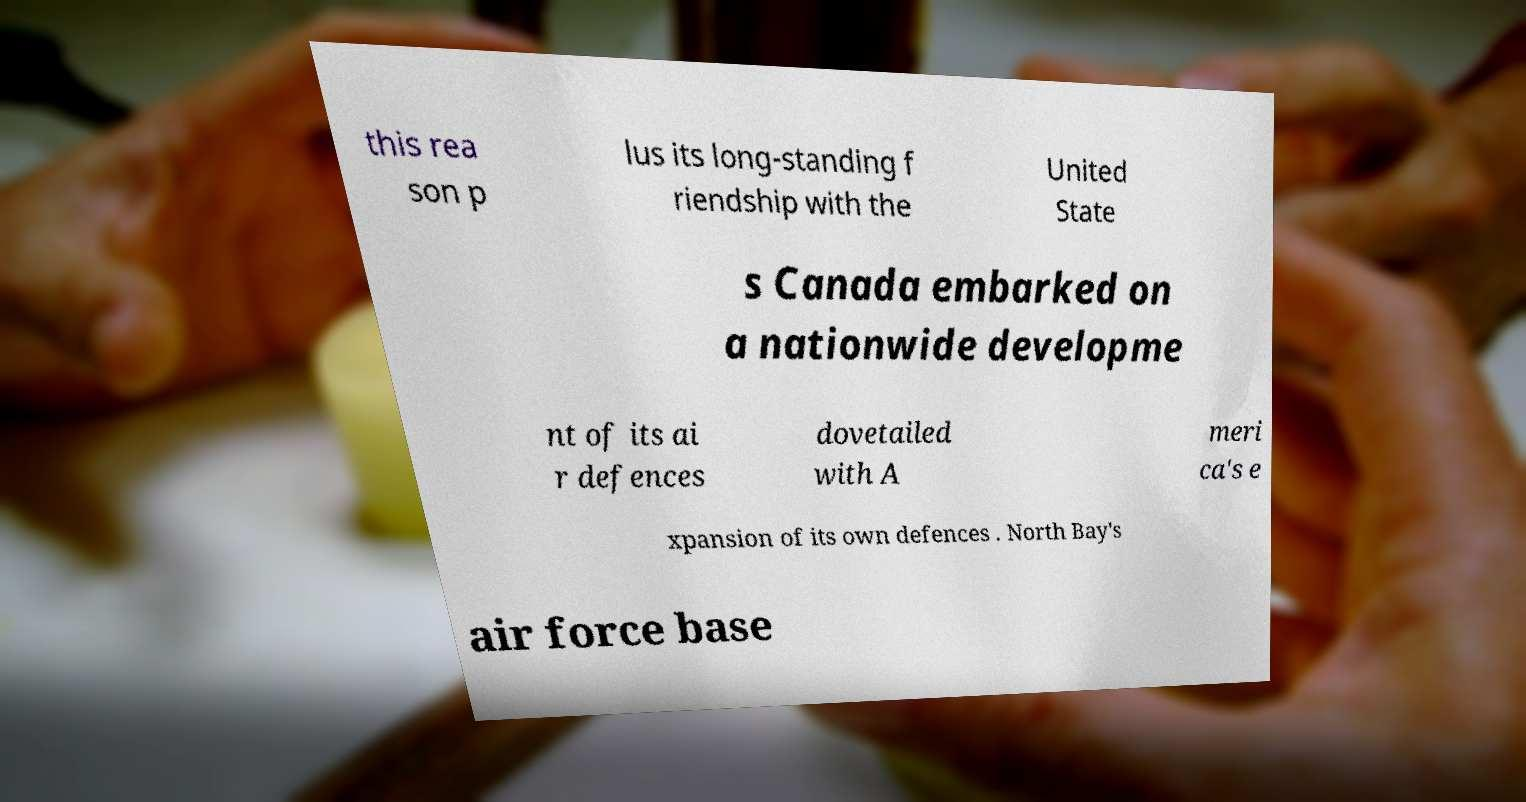Please read and relay the text visible in this image. What does it say? this rea son p lus its long-standing f riendship with the United State s Canada embarked on a nationwide developme nt of its ai r defences dovetailed with A meri ca's e xpansion of its own defences . North Bay's air force base 